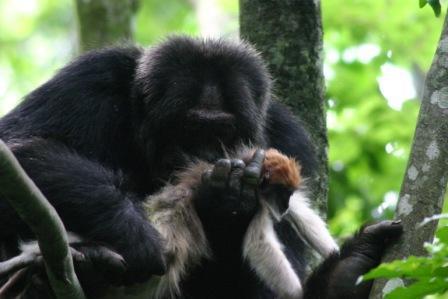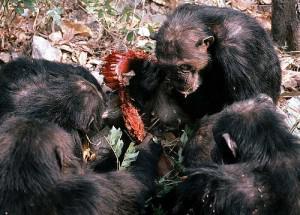The first image is the image on the left, the second image is the image on the right. Assess this claim about the two images: "An image shows at least three chimps huddled around a piece of carcass.". Correct or not? Answer yes or no. Yes. The first image is the image on the left, the second image is the image on the right. For the images shown, is this caption "A group of monkeys is eating meat in one of the images." true? Answer yes or no. Yes. 